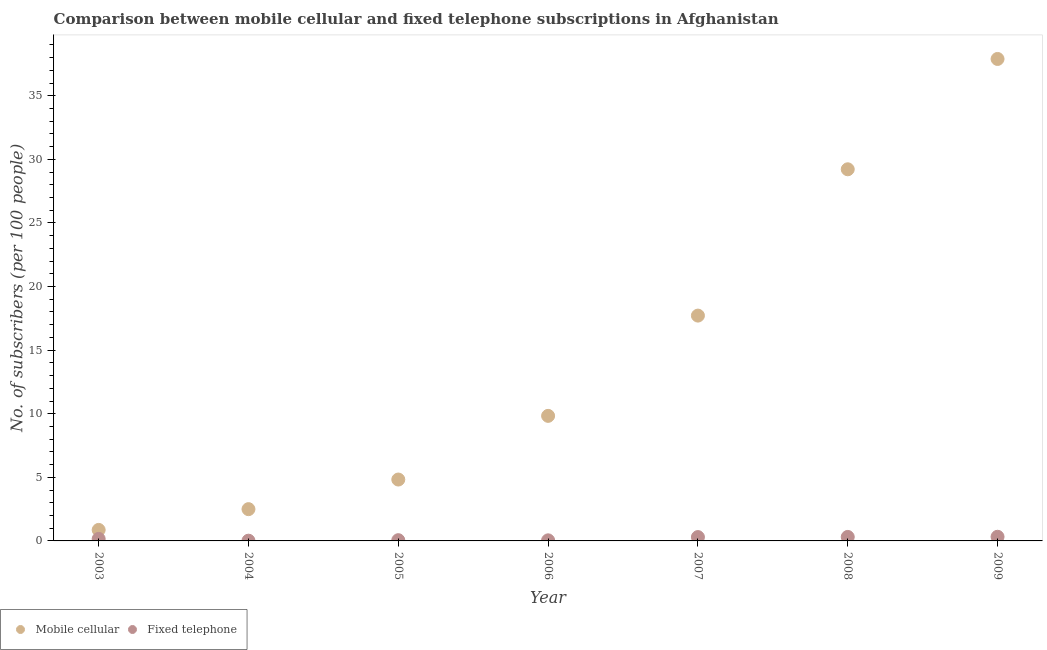How many different coloured dotlines are there?
Make the answer very short. 2. What is the number of fixed telephone subscribers in 2003?
Ensure brevity in your answer.  0.16. Across all years, what is the maximum number of mobile cellular subscribers?
Provide a short and direct response. 37.89. Across all years, what is the minimum number of mobile cellular subscribers?
Ensure brevity in your answer.  0.87. In which year was the number of fixed telephone subscribers maximum?
Make the answer very short. 2009. What is the total number of fixed telephone subscribers in the graph?
Ensure brevity in your answer.  1.22. What is the difference between the number of fixed telephone subscribers in 2005 and that in 2009?
Make the answer very short. -0.27. What is the difference between the number of fixed telephone subscribers in 2009 and the number of mobile cellular subscribers in 2008?
Keep it short and to the point. -28.89. What is the average number of mobile cellular subscribers per year?
Your answer should be very brief. 14.69. In the year 2006, what is the difference between the number of mobile cellular subscribers and number of fixed telephone subscribers?
Your answer should be compact. 9.79. In how many years, is the number of fixed telephone subscribers greater than 28?
Ensure brevity in your answer.  0. What is the ratio of the number of mobile cellular subscribers in 2007 to that in 2008?
Provide a short and direct response. 0.61. Is the number of mobile cellular subscribers in 2003 less than that in 2006?
Your response must be concise. Yes. What is the difference between the highest and the second highest number of mobile cellular subscribers?
Keep it short and to the point. 8.67. What is the difference between the highest and the lowest number of fixed telephone subscribers?
Provide a short and direct response. 0.31. How many years are there in the graph?
Your answer should be compact. 7. Does the graph contain grids?
Provide a short and direct response. No. How are the legend labels stacked?
Offer a very short reply. Horizontal. What is the title of the graph?
Provide a succinct answer. Comparison between mobile cellular and fixed telephone subscriptions in Afghanistan. Does "Birth rate" appear as one of the legend labels in the graph?
Your response must be concise. No. What is the label or title of the X-axis?
Make the answer very short. Year. What is the label or title of the Y-axis?
Keep it short and to the point. No. of subscribers (per 100 people). What is the No. of subscribers (per 100 people) in Mobile cellular in 2003?
Your answer should be compact. 0.87. What is the No. of subscribers (per 100 people) in Fixed telephone in 2003?
Offer a very short reply. 0.16. What is the No. of subscribers (per 100 people) in Mobile cellular in 2004?
Your response must be concise. 2.5. What is the No. of subscribers (per 100 people) in Fixed telephone in 2004?
Your answer should be very brief. 0.02. What is the No. of subscribers (per 100 people) in Mobile cellular in 2005?
Your response must be concise. 4.83. What is the No. of subscribers (per 100 people) of Fixed telephone in 2005?
Ensure brevity in your answer.  0.06. What is the No. of subscribers (per 100 people) of Mobile cellular in 2006?
Offer a very short reply. 9.83. What is the No. of subscribers (per 100 people) of Fixed telephone in 2006?
Provide a short and direct response. 0.05. What is the No. of subscribers (per 100 people) of Mobile cellular in 2007?
Keep it short and to the point. 17.72. What is the No. of subscribers (per 100 people) in Fixed telephone in 2007?
Offer a very short reply. 0.3. What is the No. of subscribers (per 100 people) of Mobile cellular in 2008?
Keep it short and to the point. 29.22. What is the No. of subscribers (per 100 people) in Fixed telephone in 2008?
Your answer should be very brief. 0.31. What is the No. of subscribers (per 100 people) of Mobile cellular in 2009?
Offer a terse response. 37.89. What is the No. of subscribers (per 100 people) in Fixed telephone in 2009?
Make the answer very short. 0.33. Across all years, what is the maximum No. of subscribers (per 100 people) of Mobile cellular?
Your answer should be compact. 37.89. Across all years, what is the maximum No. of subscribers (per 100 people) of Fixed telephone?
Give a very brief answer. 0.33. Across all years, what is the minimum No. of subscribers (per 100 people) in Mobile cellular?
Offer a very short reply. 0.87. Across all years, what is the minimum No. of subscribers (per 100 people) in Fixed telephone?
Ensure brevity in your answer.  0.02. What is the total No. of subscribers (per 100 people) in Mobile cellular in the graph?
Make the answer very short. 102.85. What is the total No. of subscribers (per 100 people) of Fixed telephone in the graph?
Offer a terse response. 1.22. What is the difference between the No. of subscribers (per 100 people) of Mobile cellular in 2003 and that in 2004?
Your answer should be compact. -1.63. What is the difference between the No. of subscribers (per 100 people) of Fixed telephone in 2003 and that in 2004?
Provide a succinct answer. 0.14. What is the difference between the No. of subscribers (per 100 people) of Mobile cellular in 2003 and that in 2005?
Keep it short and to the point. -3.96. What is the difference between the No. of subscribers (per 100 people) in Fixed telephone in 2003 and that in 2005?
Your response must be concise. 0.1. What is the difference between the No. of subscribers (per 100 people) of Mobile cellular in 2003 and that in 2006?
Your response must be concise. -8.97. What is the difference between the No. of subscribers (per 100 people) of Fixed telephone in 2003 and that in 2006?
Offer a very short reply. 0.11. What is the difference between the No. of subscribers (per 100 people) of Mobile cellular in 2003 and that in 2007?
Provide a short and direct response. -16.85. What is the difference between the No. of subscribers (per 100 people) of Fixed telephone in 2003 and that in 2007?
Offer a very short reply. -0.14. What is the difference between the No. of subscribers (per 100 people) in Mobile cellular in 2003 and that in 2008?
Your answer should be compact. -28.36. What is the difference between the No. of subscribers (per 100 people) of Fixed telephone in 2003 and that in 2008?
Offer a terse response. -0.15. What is the difference between the No. of subscribers (per 100 people) of Mobile cellular in 2003 and that in 2009?
Your answer should be very brief. -37.03. What is the difference between the No. of subscribers (per 100 people) of Fixed telephone in 2003 and that in 2009?
Ensure brevity in your answer.  -0.17. What is the difference between the No. of subscribers (per 100 people) of Mobile cellular in 2004 and that in 2005?
Offer a very short reply. -2.33. What is the difference between the No. of subscribers (per 100 people) in Fixed telephone in 2004 and that in 2005?
Make the answer very short. -0.04. What is the difference between the No. of subscribers (per 100 people) of Mobile cellular in 2004 and that in 2006?
Provide a succinct answer. -7.34. What is the difference between the No. of subscribers (per 100 people) of Fixed telephone in 2004 and that in 2006?
Your response must be concise. -0.03. What is the difference between the No. of subscribers (per 100 people) of Mobile cellular in 2004 and that in 2007?
Your answer should be very brief. -15.22. What is the difference between the No. of subscribers (per 100 people) in Fixed telephone in 2004 and that in 2007?
Keep it short and to the point. -0.28. What is the difference between the No. of subscribers (per 100 people) in Mobile cellular in 2004 and that in 2008?
Your response must be concise. -26.72. What is the difference between the No. of subscribers (per 100 people) in Fixed telephone in 2004 and that in 2008?
Your response must be concise. -0.29. What is the difference between the No. of subscribers (per 100 people) of Mobile cellular in 2004 and that in 2009?
Ensure brevity in your answer.  -35.4. What is the difference between the No. of subscribers (per 100 people) of Fixed telephone in 2004 and that in 2009?
Keep it short and to the point. -0.31. What is the difference between the No. of subscribers (per 100 people) of Mobile cellular in 2005 and that in 2006?
Keep it short and to the point. -5.01. What is the difference between the No. of subscribers (per 100 people) of Fixed telephone in 2005 and that in 2006?
Provide a succinct answer. 0.01. What is the difference between the No. of subscribers (per 100 people) of Mobile cellular in 2005 and that in 2007?
Provide a short and direct response. -12.89. What is the difference between the No. of subscribers (per 100 people) of Fixed telephone in 2005 and that in 2007?
Provide a short and direct response. -0.24. What is the difference between the No. of subscribers (per 100 people) in Mobile cellular in 2005 and that in 2008?
Provide a short and direct response. -24.39. What is the difference between the No. of subscribers (per 100 people) of Fixed telephone in 2005 and that in 2008?
Your answer should be very brief. -0.25. What is the difference between the No. of subscribers (per 100 people) of Mobile cellular in 2005 and that in 2009?
Offer a terse response. -33.07. What is the difference between the No. of subscribers (per 100 people) in Fixed telephone in 2005 and that in 2009?
Your answer should be compact. -0.27. What is the difference between the No. of subscribers (per 100 people) of Mobile cellular in 2006 and that in 2007?
Offer a terse response. -7.88. What is the difference between the No. of subscribers (per 100 people) of Fixed telephone in 2006 and that in 2007?
Offer a terse response. -0.26. What is the difference between the No. of subscribers (per 100 people) in Mobile cellular in 2006 and that in 2008?
Provide a short and direct response. -19.39. What is the difference between the No. of subscribers (per 100 people) of Fixed telephone in 2006 and that in 2008?
Give a very brief answer. -0.27. What is the difference between the No. of subscribers (per 100 people) in Mobile cellular in 2006 and that in 2009?
Ensure brevity in your answer.  -28.06. What is the difference between the No. of subscribers (per 100 people) of Fixed telephone in 2006 and that in 2009?
Keep it short and to the point. -0.28. What is the difference between the No. of subscribers (per 100 people) of Mobile cellular in 2007 and that in 2008?
Provide a succinct answer. -11.5. What is the difference between the No. of subscribers (per 100 people) in Fixed telephone in 2007 and that in 2008?
Make the answer very short. -0.01. What is the difference between the No. of subscribers (per 100 people) of Mobile cellular in 2007 and that in 2009?
Your answer should be compact. -20.18. What is the difference between the No. of subscribers (per 100 people) in Fixed telephone in 2007 and that in 2009?
Ensure brevity in your answer.  -0.02. What is the difference between the No. of subscribers (per 100 people) in Mobile cellular in 2008 and that in 2009?
Give a very brief answer. -8.67. What is the difference between the No. of subscribers (per 100 people) in Fixed telephone in 2008 and that in 2009?
Provide a short and direct response. -0.01. What is the difference between the No. of subscribers (per 100 people) in Mobile cellular in 2003 and the No. of subscribers (per 100 people) in Fixed telephone in 2004?
Make the answer very short. 0.85. What is the difference between the No. of subscribers (per 100 people) in Mobile cellular in 2003 and the No. of subscribers (per 100 people) in Fixed telephone in 2005?
Offer a terse response. 0.81. What is the difference between the No. of subscribers (per 100 people) in Mobile cellular in 2003 and the No. of subscribers (per 100 people) in Fixed telephone in 2006?
Provide a short and direct response. 0.82. What is the difference between the No. of subscribers (per 100 people) of Mobile cellular in 2003 and the No. of subscribers (per 100 people) of Fixed telephone in 2007?
Offer a terse response. 0.56. What is the difference between the No. of subscribers (per 100 people) of Mobile cellular in 2003 and the No. of subscribers (per 100 people) of Fixed telephone in 2008?
Your answer should be very brief. 0.55. What is the difference between the No. of subscribers (per 100 people) of Mobile cellular in 2003 and the No. of subscribers (per 100 people) of Fixed telephone in 2009?
Your response must be concise. 0.54. What is the difference between the No. of subscribers (per 100 people) of Mobile cellular in 2004 and the No. of subscribers (per 100 people) of Fixed telephone in 2005?
Give a very brief answer. 2.44. What is the difference between the No. of subscribers (per 100 people) in Mobile cellular in 2004 and the No. of subscribers (per 100 people) in Fixed telephone in 2006?
Give a very brief answer. 2.45. What is the difference between the No. of subscribers (per 100 people) of Mobile cellular in 2004 and the No. of subscribers (per 100 people) of Fixed telephone in 2007?
Provide a short and direct response. 2.2. What is the difference between the No. of subscribers (per 100 people) in Mobile cellular in 2004 and the No. of subscribers (per 100 people) in Fixed telephone in 2008?
Offer a very short reply. 2.18. What is the difference between the No. of subscribers (per 100 people) of Mobile cellular in 2004 and the No. of subscribers (per 100 people) of Fixed telephone in 2009?
Offer a terse response. 2.17. What is the difference between the No. of subscribers (per 100 people) of Mobile cellular in 2005 and the No. of subscribers (per 100 people) of Fixed telephone in 2006?
Your answer should be compact. 4.78. What is the difference between the No. of subscribers (per 100 people) of Mobile cellular in 2005 and the No. of subscribers (per 100 people) of Fixed telephone in 2007?
Your response must be concise. 4.53. What is the difference between the No. of subscribers (per 100 people) of Mobile cellular in 2005 and the No. of subscribers (per 100 people) of Fixed telephone in 2008?
Offer a terse response. 4.51. What is the difference between the No. of subscribers (per 100 people) of Mobile cellular in 2005 and the No. of subscribers (per 100 people) of Fixed telephone in 2009?
Your response must be concise. 4.5. What is the difference between the No. of subscribers (per 100 people) in Mobile cellular in 2006 and the No. of subscribers (per 100 people) in Fixed telephone in 2007?
Your response must be concise. 9.53. What is the difference between the No. of subscribers (per 100 people) of Mobile cellular in 2006 and the No. of subscribers (per 100 people) of Fixed telephone in 2008?
Offer a very short reply. 9.52. What is the difference between the No. of subscribers (per 100 people) of Mobile cellular in 2006 and the No. of subscribers (per 100 people) of Fixed telephone in 2009?
Your answer should be very brief. 9.51. What is the difference between the No. of subscribers (per 100 people) of Mobile cellular in 2007 and the No. of subscribers (per 100 people) of Fixed telephone in 2008?
Your answer should be very brief. 17.4. What is the difference between the No. of subscribers (per 100 people) in Mobile cellular in 2007 and the No. of subscribers (per 100 people) in Fixed telephone in 2009?
Offer a terse response. 17.39. What is the difference between the No. of subscribers (per 100 people) in Mobile cellular in 2008 and the No. of subscribers (per 100 people) in Fixed telephone in 2009?
Your answer should be very brief. 28.89. What is the average No. of subscribers (per 100 people) of Mobile cellular per year?
Your answer should be compact. 14.69. What is the average No. of subscribers (per 100 people) of Fixed telephone per year?
Offer a terse response. 0.17. In the year 2003, what is the difference between the No. of subscribers (per 100 people) in Mobile cellular and No. of subscribers (per 100 people) in Fixed telephone?
Your answer should be very brief. 0.71. In the year 2004, what is the difference between the No. of subscribers (per 100 people) of Mobile cellular and No. of subscribers (per 100 people) of Fixed telephone?
Provide a succinct answer. 2.48. In the year 2005, what is the difference between the No. of subscribers (per 100 people) in Mobile cellular and No. of subscribers (per 100 people) in Fixed telephone?
Ensure brevity in your answer.  4.77. In the year 2006, what is the difference between the No. of subscribers (per 100 people) in Mobile cellular and No. of subscribers (per 100 people) in Fixed telephone?
Your response must be concise. 9.79. In the year 2007, what is the difference between the No. of subscribers (per 100 people) in Mobile cellular and No. of subscribers (per 100 people) in Fixed telephone?
Provide a succinct answer. 17.41. In the year 2008, what is the difference between the No. of subscribers (per 100 people) in Mobile cellular and No. of subscribers (per 100 people) in Fixed telephone?
Provide a short and direct response. 28.91. In the year 2009, what is the difference between the No. of subscribers (per 100 people) in Mobile cellular and No. of subscribers (per 100 people) in Fixed telephone?
Your answer should be compact. 37.57. What is the ratio of the No. of subscribers (per 100 people) of Mobile cellular in 2003 to that in 2004?
Provide a short and direct response. 0.35. What is the ratio of the No. of subscribers (per 100 people) in Fixed telephone in 2003 to that in 2004?
Provide a succinct answer. 8.58. What is the ratio of the No. of subscribers (per 100 people) of Mobile cellular in 2003 to that in 2005?
Keep it short and to the point. 0.18. What is the ratio of the No. of subscribers (per 100 people) in Fixed telephone in 2003 to that in 2005?
Offer a terse response. 2.71. What is the ratio of the No. of subscribers (per 100 people) of Mobile cellular in 2003 to that in 2006?
Offer a very short reply. 0.09. What is the ratio of the No. of subscribers (per 100 people) of Fixed telephone in 2003 to that in 2006?
Your answer should be very brief. 3.42. What is the ratio of the No. of subscribers (per 100 people) in Mobile cellular in 2003 to that in 2007?
Offer a very short reply. 0.05. What is the ratio of the No. of subscribers (per 100 people) in Fixed telephone in 2003 to that in 2007?
Keep it short and to the point. 0.53. What is the ratio of the No. of subscribers (per 100 people) of Mobile cellular in 2003 to that in 2008?
Offer a very short reply. 0.03. What is the ratio of the No. of subscribers (per 100 people) of Fixed telephone in 2003 to that in 2008?
Ensure brevity in your answer.  0.51. What is the ratio of the No. of subscribers (per 100 people) of Mobile cellular in 2003 to that in 2009?
Make the answer very short. 0.02. What is the ratio of the No. of subscribers (per 100 people) in Fixed telephone in 2003 to that in 2009?
Give a very brief answer. 0.49. What is the ratio of the No. of subscribers (per 100 people) in Mobile cellular in 2004 to that in 2005?
Offer a very short reply. 0.52. What is the ratio of the No. of subscribers (per 100 people) in Fixed telephone in 2004 to that in 2005?
Ensure brevity in your answer.  0.32. What is the ratio of the No. of subscribers (per 100 people) of Mobile cellular in 2004 to that in 2006?
Make the answer very short. 0.25. What is the ratio of the No. of subscribers (per 100 people) in Fixed telephone in 2004 to that in 2006?
Ensure brevity in your answer.  0.4. What is the ratio of the No. of subscribers (per 100 people) in Mobile cellular in 2004 to that in 2007?
Give a very brief answer. 0.14. What is the ratio of the No. of subscribers (per 100 people) of Fixed telephone in 2004 to that in 2007?
Provide a short and direct response. 0.06. What is the ratio of the No. of subscribers (per 100 people) of Mobile cellular in 2004 to that in 2008?
Make the answer very short. 0.09. What is the ratio of the No. of subscribers (per 100 people) in Fixed telephone in 2004 to that in 2008?
Your answer should be very brief. 0.06. What is the ratio of the No. of subscribers (per 100 people) in Mobile cellular in 2004 to that in 2009?
Your answer should be very brief. 0.07. What is the ratio of the No. of subscribers (per 100 people) of Fixed telephone in 2004 to that in 2009?
Make the answer very short. 0.06. What is the ratio of the No. of subscribers (per 100 people) in Mobile cellular in 2005 to that in 2006?
Make the answer very short. 0.49. What is the ratio of the No. of subscribers (per 100 people) of Fixed telephone in 2005 to that in 2006?
Your answer should be compact. 1.26. What is the ratio of the No. of subscribers (per 100 people) of Mobile cellular in 2005 to that in 2007?
Your response must be concise. 0.27. What is the ratio of the No. of subscribers (per 100 people) in Fixed telephone in 2005 to that in 2007?
Offer a very short reply. 0.19. What is the ratio of the No. of subscribers (per 100 people) of Mobile cellular in 2005 to that in 2008?
Provide a succinct answer. 0.17. What is the ratio of the No. of subscribers (per 100 people) in Fixed telephone in 2005 to that in 2008?
Offer a terse response. 0.19. What is the ratio of the No. of subscribers (per 100 people) in Mobile cellular in 2005 to that in 2009?
Provide a short and direct response. 0.13. What is the ratio of the No. of subscribers (per 100 people) in Fixed telephone in 2005 to that in 2009?
Your answer should be very brief. 0.18. What is the ratio of the No. of subscribers (per 100 people) in Mobile cellular in 2006 to that in 2007?
Your response must be concise. 0.56. What is the ratio of the No. of subscribers (per 100 people) in Fixed telephone in 2006 to that in 2007?
Your response must be concise. 0.15. What is the ratio of the No. of subscribers (per 100 people) of Mobile cellular in 2006 to that in 2008?
Keep it short and to the point. 0.34. What is the ratio of the No. of subscribers (per 100 people) in Fixed telephone in 2006 to that in 2008?
Give a very brief answer. 0.15. What is the ratio of the No. of subscribers (per 100 people) in Mobile cellular in 2006 to that in 2009?
Keep it short and to the point. 0.26. What is the ratio of the No. of subscribers (per 100 people) in Fixed telephone in 2006 to that in 2009?
Offer a terse response. 0.14. What is the ratio of the No. of subscribers (per 100 people) of Mobile cellular in 2007 to that in 2008?
Provide a succinct answer. 0.61. What is the ratio of the No. of subscribers (per 100 people) in Fixed telephone in 2007 to that in 2008?
Offer a very short reply. 0.96. What is the ratio of the No. of subscribers (per 100 people) of Mobile cellular in 2007 to that in 2009?
Offer a terse response. 0.47. What is the ratio of the No. of subscribers (per 100 people) of Fixed telephone in 2007 to that in 2009?
Offer a terse response. 0.93. What is the ratio of the No. of subscribers (per 100 people) of Mobile cellular in 2008 to that in 2009?
Offer a very short reply. 0.77. What is the ratio of the No. of subscribers (per 100 people) in Fixed telephone in 2008 to that in 2009?
Keep it short and to the point. 0.96. What is the difference between the highest and the second highest No. of subscribers (per 100 people) of Mobile cellular?
Offer a very short reply. 8.67. What is the difference between the highest and the second highest No. of subscribers (per 100 people) of Fixed telephone?
Keep it short and to the point. 0.01. What is the difference between the highest and the lowest No. of subscribers (per 100 people) in Mobile cellular?
Offer a terse response. 37.03. What is the difference between the highest and the lowest No. of subscribers (per 100 people) of Fixed telephone?
Keep it short and to the point. 0.31. 